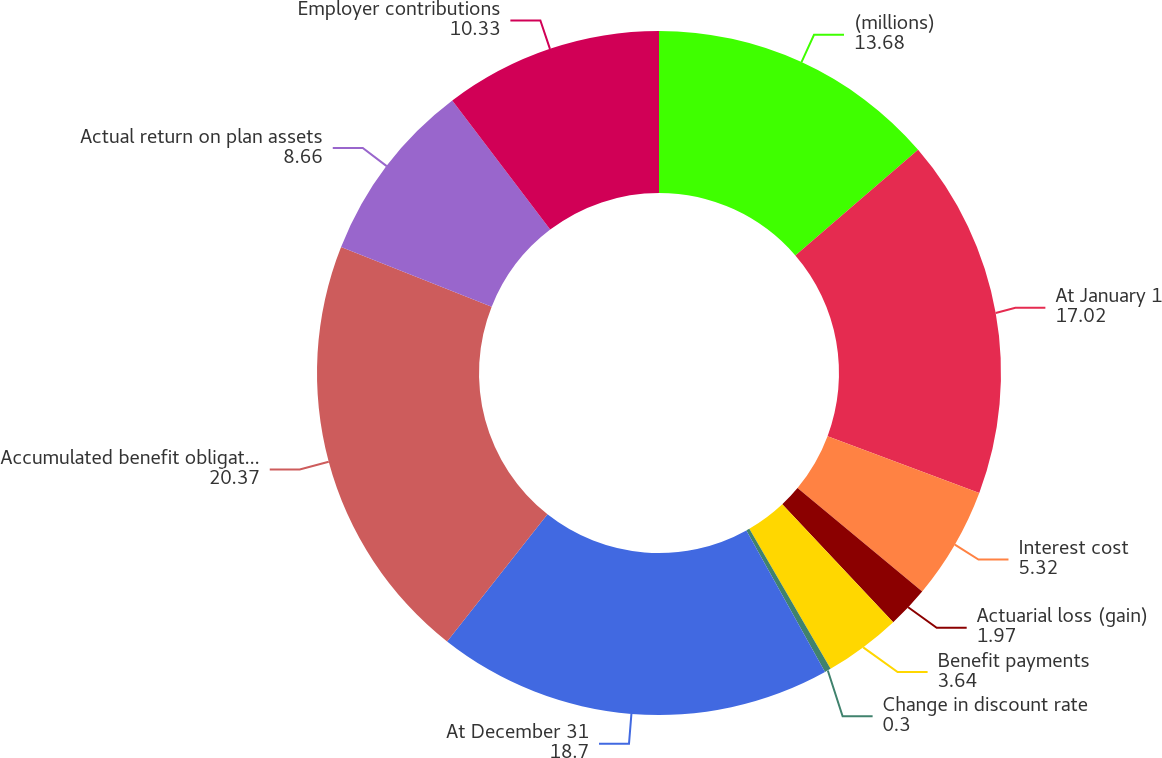<chart> <loc_0><loc_0><loc_500><loc_500><pie_chart><fcel>(millions)<fcel>At January 1<fcel>Interest cost<fcel>Actuarial loss (gain)<fcel>Benefit payments<fcel>Change in discount rate<fcel>At December 31<fcel>Accumulated benefit obligation<fcel>Actual return on plan assets<fcel>Employer contributions<nl><fcel>13.68%<fcel>17.02%<fcel>5.32%<fcel>1.97%<fcel>3.64%<fcel>0.3%<fcel>18.7%<fcel>20.37%<fcel>8.66%<fcel>10.33%<nl></chart> 